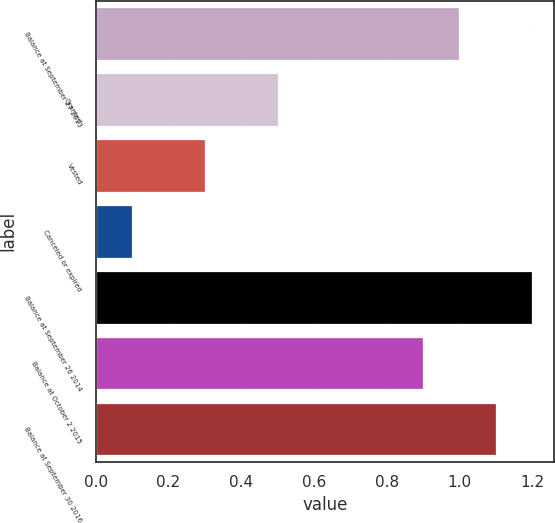<chart> <loc_0><loc_0><loc_500><loc_500><bar_chart><fcel>Balance at September 27 2013<fcel>Granted<fcel>Vested<fcel>Canceled or expired<fcel>Balance at September 26 2014<fcel>Balance at October 2 2015<fcel>Balance at September 30 2016<nl><fcel>1<fcel>0.5<fcel>0.3<fcel>0.1<fcel>1.2<fcel>0.9<fcel>1.1<nl></chart> 